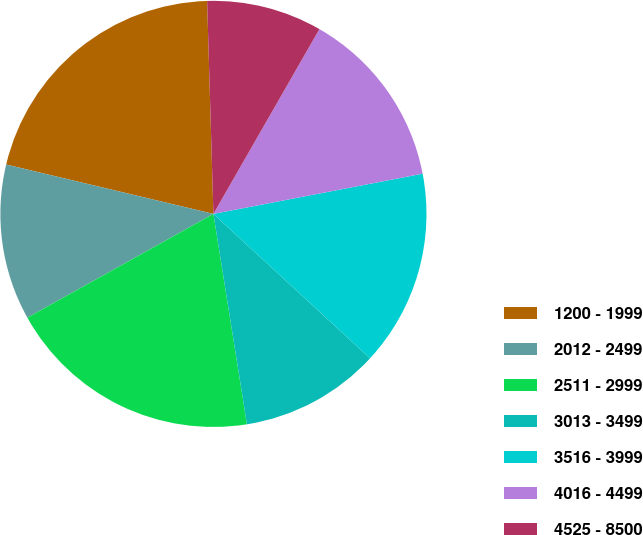Convert chart to OTSL. <chart><loc_0><loc_0><loc_500><loc_500><pie_chart><fcel>1200 - 1999<fcel>2012 - 2499<fcel>2511 - 2999<fcel>3013 - 3499<fcel>3516 - 3999<fcel>4016 - 4499<fcel>4525 - 8500<nl><fcel>20.81%<fcel>11.82%<fcel>19.42%<fcel>10.63%<fcel>14.88%<fcel>13.69%<fcel>8.76%<nl></chart> 